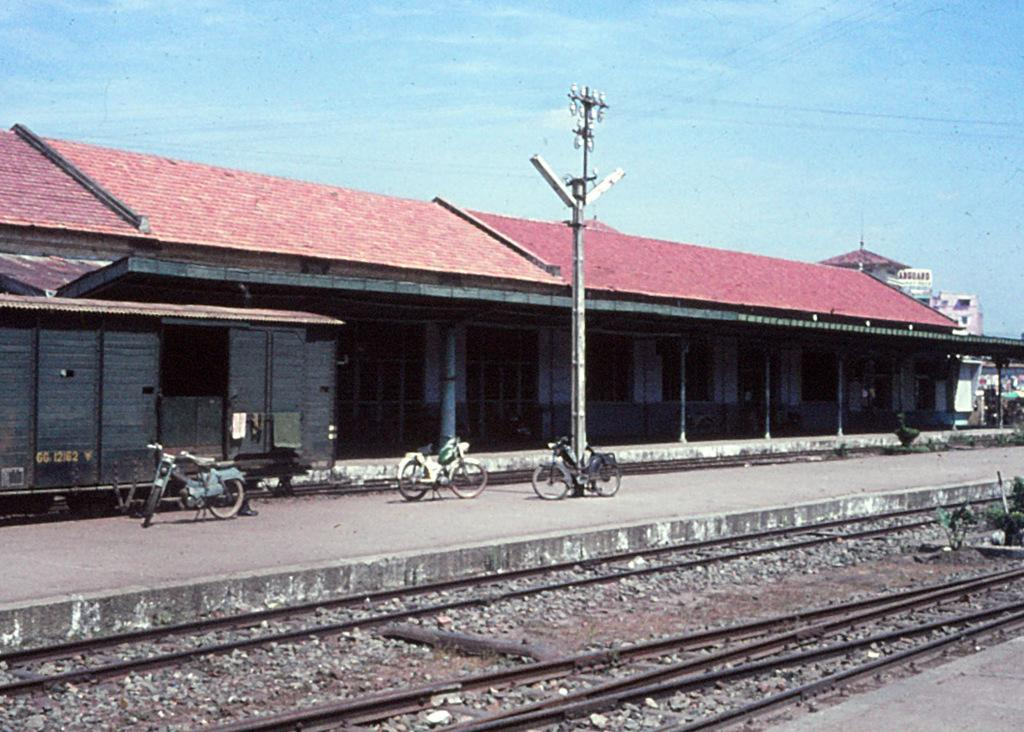What type of structure is in the image? There is a building in the image. What is located in front of the building? There is a power line pole and a track in front of the building. What can be seen on the track? Bicycles are present on the track. What type of transportation infrastructure is visible in the image? There is a railway track and a platform visible in the image. What is visible at the top of the image? The sky is visible at the top of the image. What type of skirt is the girl wearing in the image? There is no girl or skirt present in the image. What territory does the building belong to in the image? The image does not provide information about the territory or ownership of the building. 